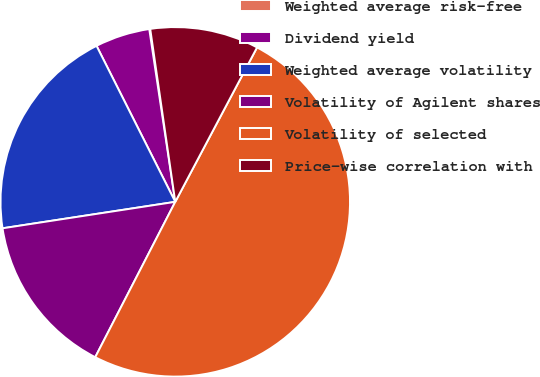Convert chart. <chart><loc_0><loc_0><loc_500><loc_500><pie_chart><fcel>Weighted average risk-free<fcel>Dividend yield<fcel>Weighted average volatility<fcel>Volatility of Agilent shares<fcel>Volatility of selected<fcel>Price-wise correlation with<nl><fcel>0.09%<fcel>5.06%<fcel>19.98%<fcel>15.01%<fcel>49.82%<fcel>10.04%<nl></chart> 